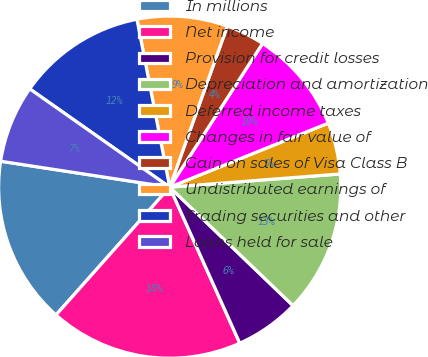Convert chart to OTSL. <chart><loc_0><loc_0><loc_500><loc_500><pie_chart><fcel>In millions<fcel>Net income<fcel>Provision for credit losses<fcel>Depreciation and amortization<fcel>Deferred income taxes<fcel>Changes in fair value of<fcel>Gain on sales of Visa Class B<fcel>Undistributed earnings of<fcel>Trading securities and other<fcel>Loans held for sale<nl><fcel>15.85%<fcel>18.29%<fcel>6.1%<fcel>13.41%<fcel>4.88%<fcel>9.76%<fcel>3.66%<fcel>8.54%<fcel>12.19%<fcel>7.32%<nl></chart> 